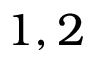<formula> <loc_0><loc_0><loc_500><loc_500>1 , 2</formula> 